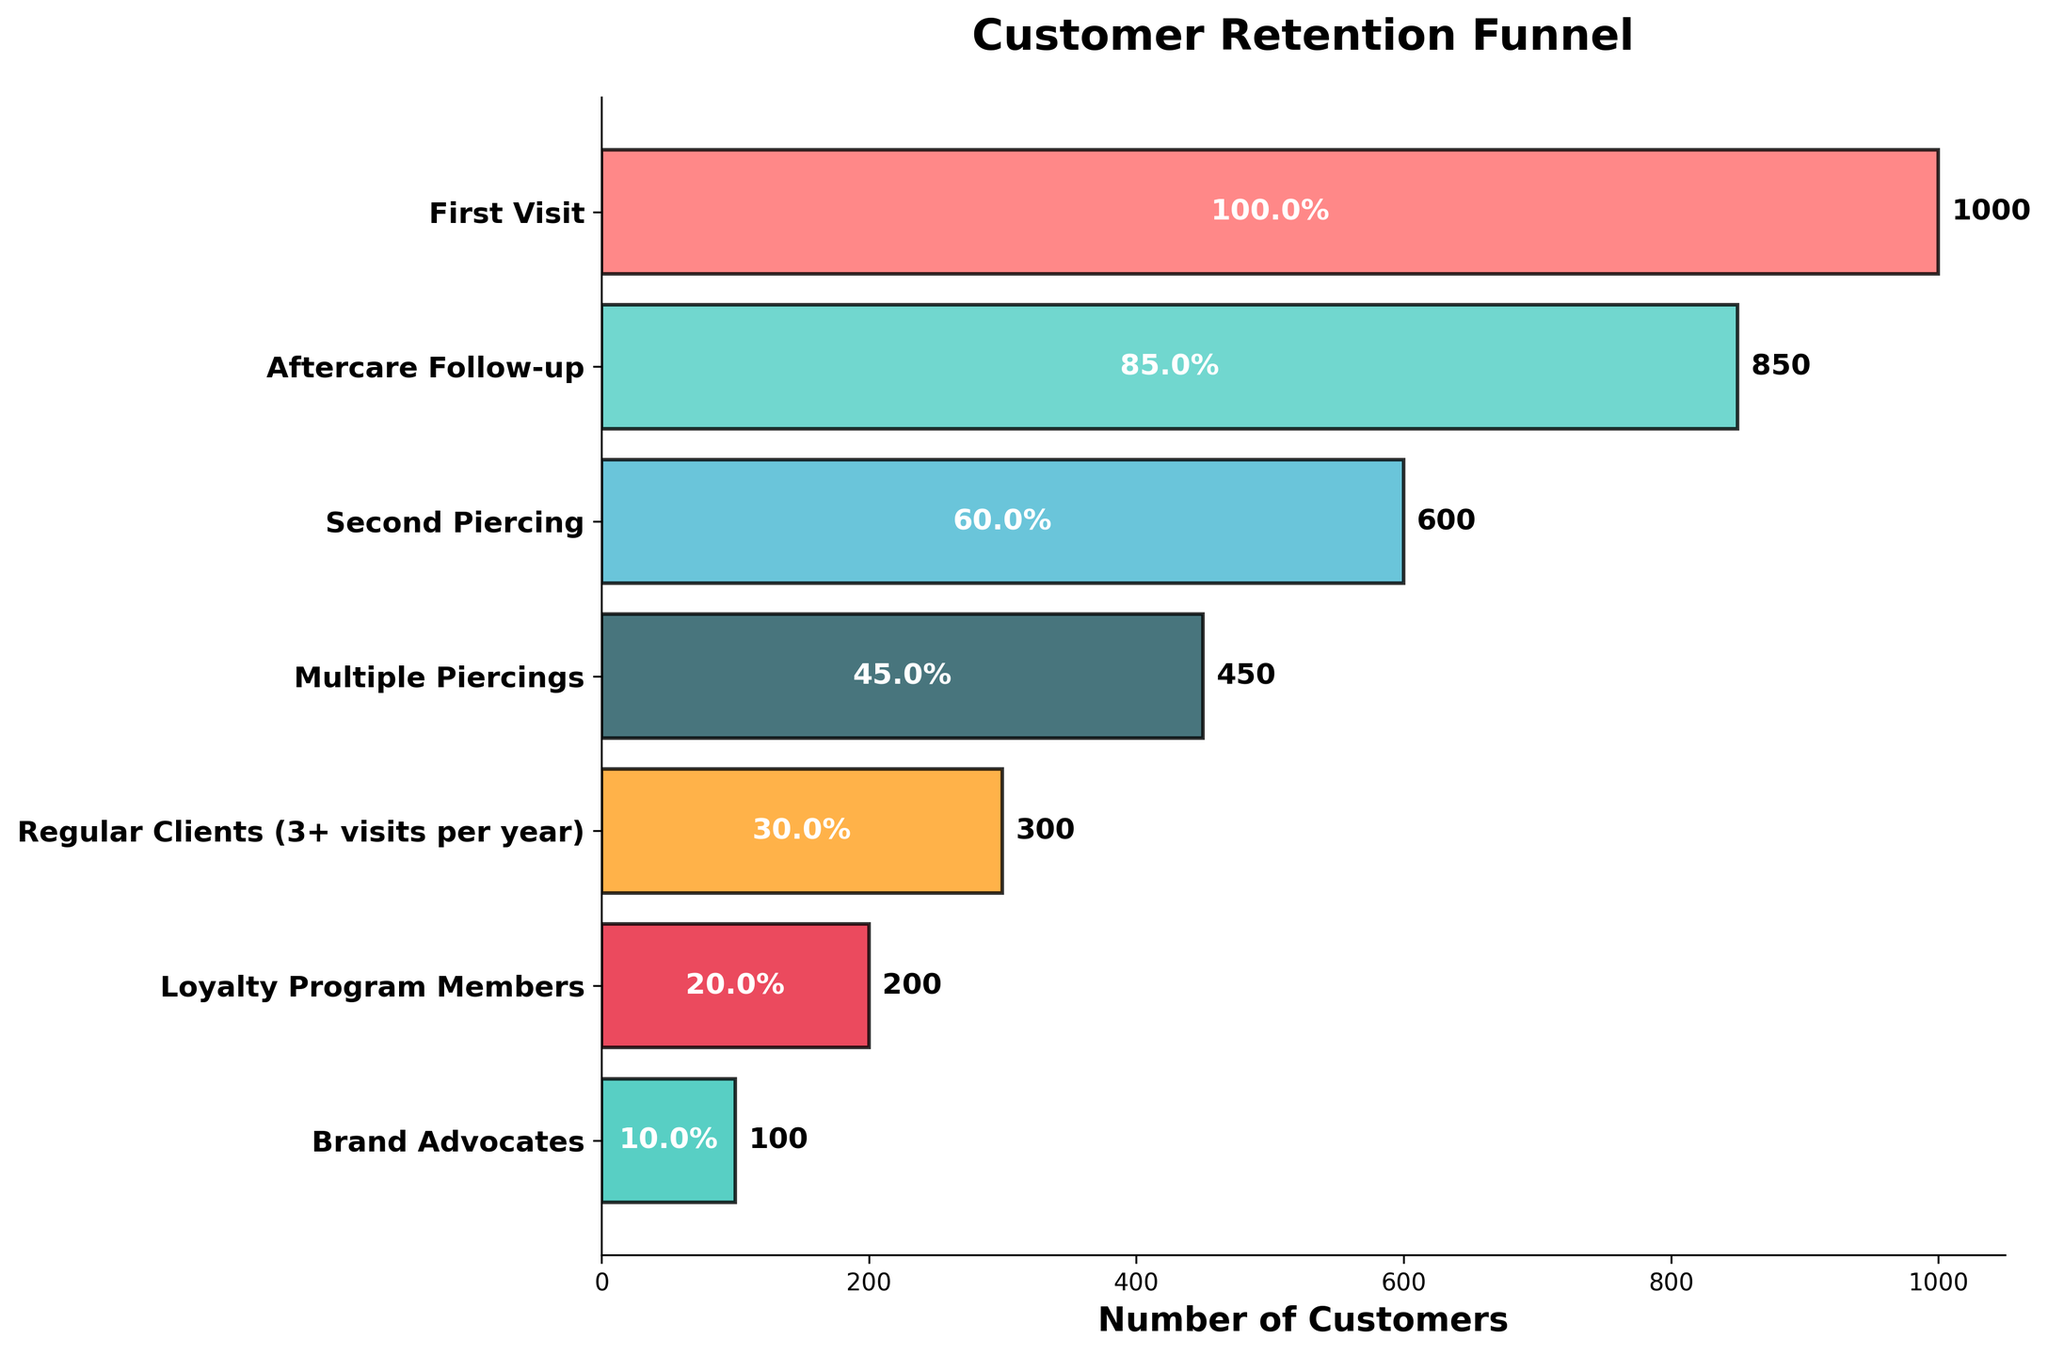How many customers are in the first stage of the funnel? The figure shows various stages with the number of customers in each stage. The first stage corresponds to "First Visit." By looking at the figure, it states "1000" customers at the "First Visit" stage.
Answer: 1000 What percentage of first visit customers move on to the aftercare follow-up stage? To find the percentage, identify the number of customers at each stage. Divide the number of "Aftercare Follow-up" customers by "First Visit" customers, then multiply by 100: (850 / 1000) * 100% = 85%.
Answer: 85% How many customers are lost between the second piercing and multiple piercings stages? Determine the number of customers at the "Second Piercing" stage (600) and the "Multiple Piercings" stage (450). Subtract the latter from the former: 600 - 450.
Answer: 150 What is the total number of customers remaining from the "Second Piercing" stage to the end? Sum the number of customers from "Second Piercing" to "Brand Advocates": 600 (Second Piercing) + 450 (Multiple Piercings) + 300 (Regular Clients) + 200 (Loyalty Program Members) + 100 (Brand Advocates).
Answer: 1650 What percentage of customers in the loyal patrons stage (3+ visits per year) are also brand advocates? Identify the number of customers in each stage and calculate the percentage of "Brand Advocates" over "Regular Clients": (100 / 300) * 100% = 33.33%.
Answer: 33.33% Which stage has the most significant drop in the number of customers compared to the previous stage? Compute the drop for each transition: "First Visit" to "Aftercare Follow-up" (1000 - 850 = 150), "Aftercare Follow-up" to "Second Piercing" (850 - 600 = 250), "Second Piercing" to "Multiple Piercings" (600 - 450 = 150), "Multiple Piercings" to "Regular Clients" (450 - 300 = 150), "Regular Clients" to "Loyalty Program Members" (300 - 200 = 100), "Loyalty Program Members" to "Brand Advocates" (200 - 100 = 100). The largest drop is from "Aftercare Follow-up" to "Second Piercing."
Answer: Aftercare Follow-up to Second Piercing Of the customers who join the loyalty program, what percentage become brand advocates? Calculate the percentage of "Loyalty Program Members" who become "Brand Advocates": (100 / 200) * 100% = 50%.
Answer: 50% What is the ratio of multiple piercing customers to loyalty program members? Determine the number of customers in "Multiple Piercings" (450) and "Loyalty Program Members" (200) stages and find their ratio: 450 / 200 = 2.25.
Answer: 2.25 Which stage sees less than half of the original 1000 visitors remaining? Identify stages where the remaining customers are fewer than half of the "First Visit" customers (less than 500). Only "Multiple Piercings" (450), "Regular Clients" (300), "Loyalty Program Members" (200), and "Brand Advocates" (100) fall below this threshold.
Answer: Multiple Piercings, Regular Clients, Loyalty Program Members, Brand Advocates 